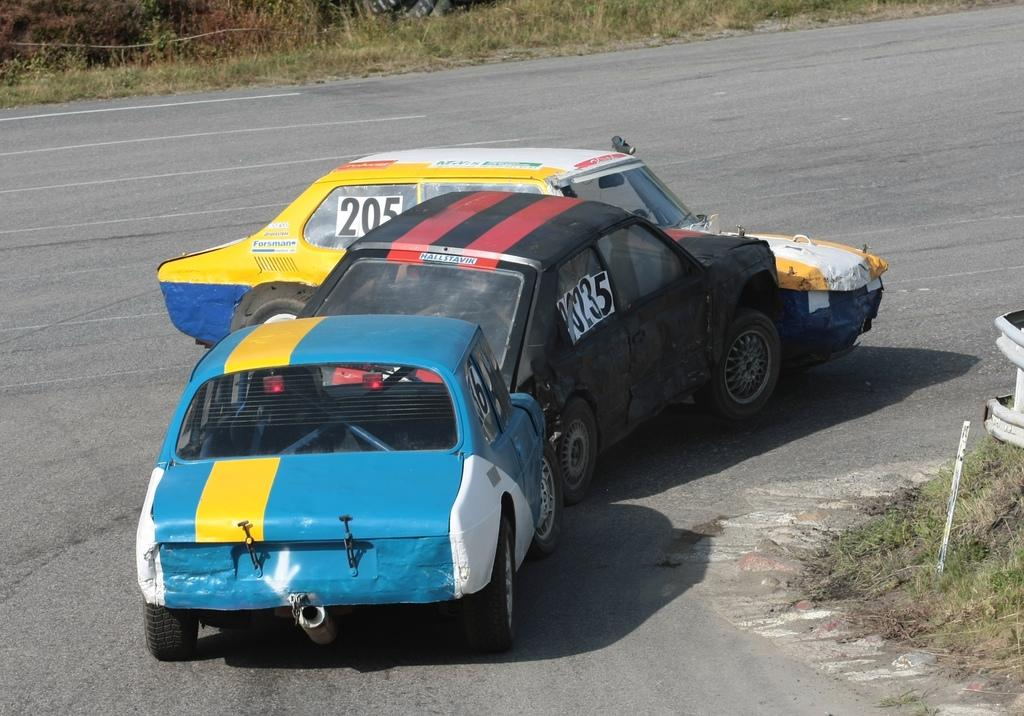How many cars can be seen on the road in the image? There are three cars on the road in the image. What type of vegetation is visible in the image? There is grass visible in the image. How many oranges are being transported by the cars in the image? There is no information about oranges or any other cargo being transported by the cars in the image. What nation is depicted in the image? The image does not depict any specific nation; it only shows cars on a road and grass. 